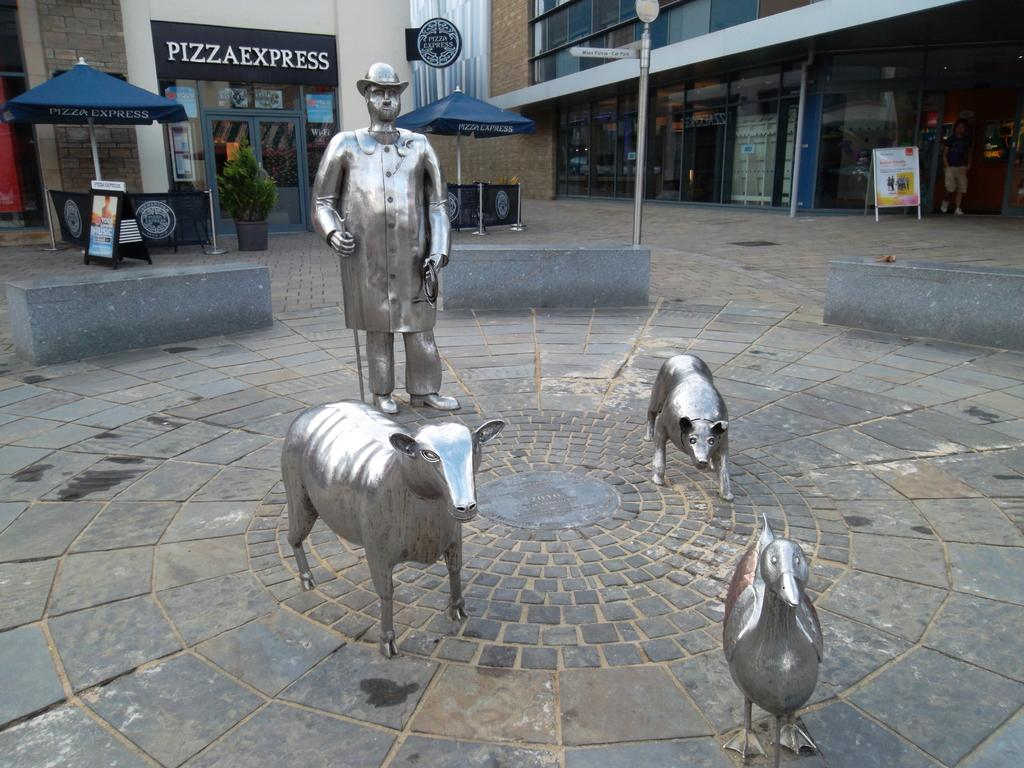What is the main subject of the image? There is a statue of a person in the image. What other statues can be seen in the image? There are statues of animals on the ground in the image. What can be seen in the background of the image? There are buildings visible in the background of the image. What time of day is it in the image, considering the presence of the night? The image does not depict a night scene, as there is no mention of it in the provided facts. 